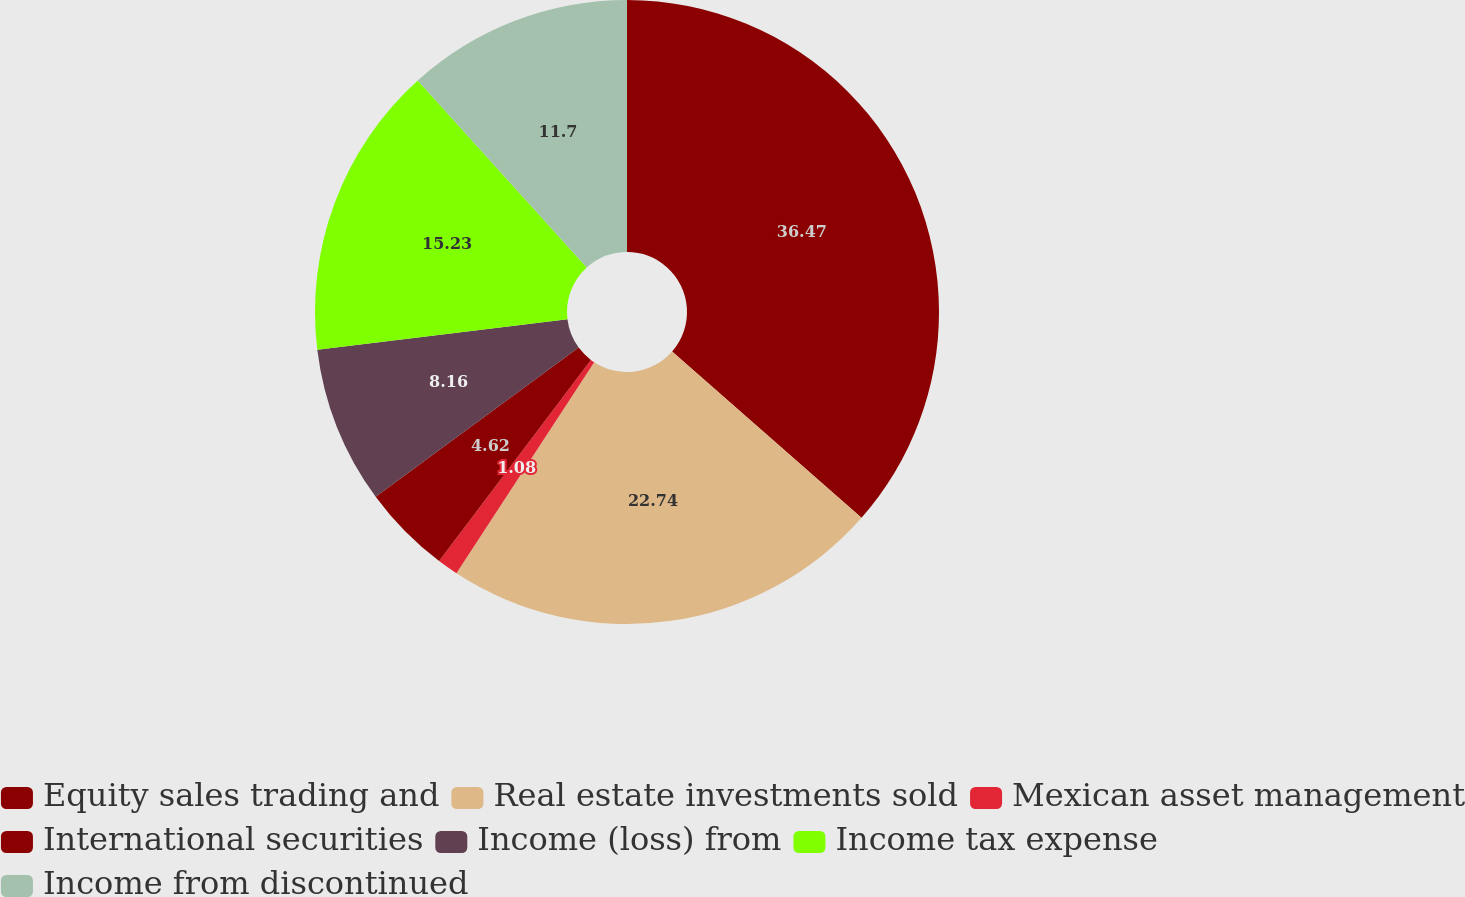<chart> <loc_0><loc_0><loc_500><loc_500><pie_chart><fcel>Equity sales trading and<fcel>Real estate investments sold<fcel>Mexican asset management<fcel>International securities<fcel>Income (loss) from<fcel>Income tax expense<fcel>Income from discontinued<nl><fcel>36.46%<fcel>22.74%<fcel>1.08%<fcel>4.62%<fcel>8.16%<fcel>15.23%<fcel>11.7%<nl></chart> 